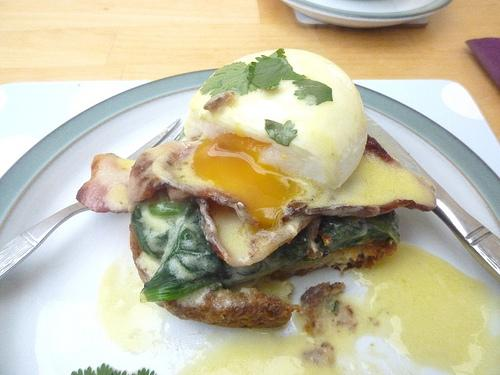What is the state of the egg yolk on the plate? The egg yolk is runny and yellow in color. In what order are the ingredients layered on the eggs benedict dish? The layers are, from bottom to top: english muffin, green spinach, pink canadian bacon, and runny yellow egg yolk. Describe the design on the plate and its edge. The plate has a white base with a blue border and a blue stripe along the edge. Which breakfast dish is displayed in the image and what sauce is on top of it? Eggs benedict is displayed in the image with yellow hollandaise sauce on top of it. Describe the surface the plate is placed on and any visible napkin in the image. The plate is placed on a light brown wooden table with a corner of a purple napkin visible. Mention some of the cutlery items present in the image along with their materials. There is a silver shiny butter knife and a shiny silver eating fork on the plate. Explain the interaction between the fork and the food on the plate. The food is laying over the fork, with a bit of torn-off meat resting near the fork's prongs. How many different main ingredients are there in the sandwich, and what are their colors? There are four main ingredients: green spinach, pink canadian bacon, brown english muffin, and yellow egg yolk. What type of dish is shown in the image and what are the main ingredients? The dish is an eggs benedict with canadian bacon, spinach, runny egg yolk, and an english muffin. Identify the primary objects on the plate and their colors. Yellow liquid egg yolk, pink canadian bacon, green spinach, brown english muffin, and fresh green parsley leaves are on the plate. 